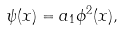Convert formula to latex. <formula><loc_0><loc_0><loc_500><loc_500>\psi ( { x } ) = a _ { 1 } \phi ^ { 2 } ( { x } ) ,</formula> 